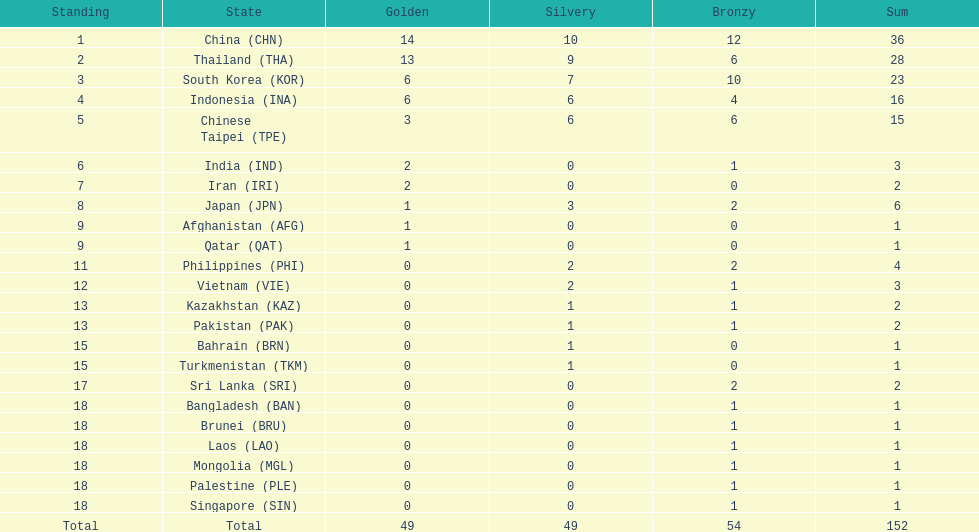What was the number of medals earned by indonesia (ina) ? 16. 